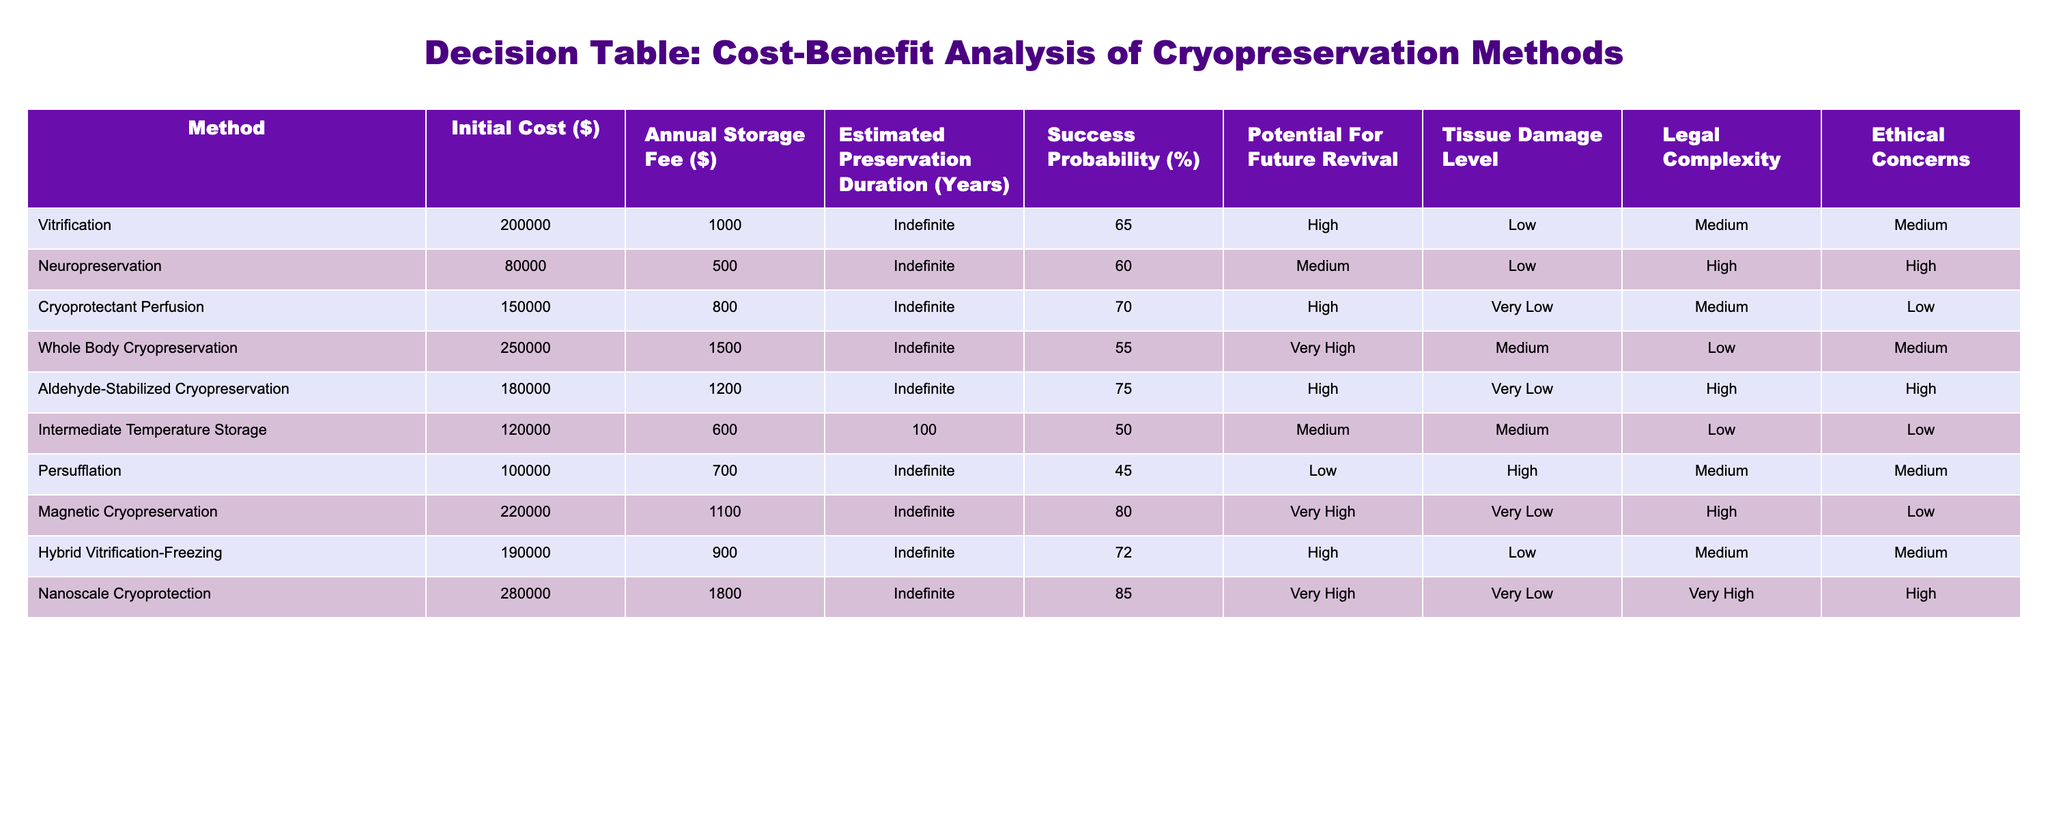What is the initial cost of Neuropreservation? The table lists the initial cost for Neuropreservation, which is $80,000.
Answer: 80,000 Which method has the highest success probability? In the table, Nanoscale Cryoprotection shows the highest success probability at 85%.
Answer: 85% What is the average annual storage fee for all methods? To find the average annual storage fee, we sum the storage fees: 1000 + 500 + 800 + 1500 + 1200 + 600 + 700 + 1100 + 1800 = 8200. Then, we divide by the number of methods (9): 8200/9 = approximately 911.11.
Answer: Approximately 911.11 Is the potential for future revival low for any methods? By reviewing the table, it can be observed that the potential for future revival is labeled as low for both Persufflation and some other methods. Therefore, it is true that at least two methods have low potential for future revival.
Answer: Yes Which method has the lowest tissue damage level and what is its success probability? The methods with the lowest tissue damage level are Cryoprotectant Perfusion and Aldehyde-Stabilized Cryopreservation, both displaying a tissue damage level of Very Low. Cryoprotectant Perfusion has a success probability of 70%, while Aldehyde-Stabilized Cryopreservation has 75%. Thus, Aldehyde-Stabilized Cryopreservation has the higher success probability at 75%.
Answer: Aldehyde-Stabilized Cryopreservation, 75% Which cryopreservation method is both high in success probability and very low in ethical concerns? The table reveals that Nanoscale Cryoprotection is the only method identified that has a success probability of 85% and is categorized as having very low ethical concerns.
Answer: Nanoscale Cryoprotection What is the cost difference between Whole Body Cryopreservation and Magnetic Cryopreservation? The initial cost of Whole Body Cryopreservation is $250,000 and that of Magnetic Cryopreservation is $220,000. Calculating the difference, we find $250,000 - $220,000 = $30,000.
Answer: 30,000 Are the legal complexities associated with Vitrification and Neuropreservation the same? By examining the table, Vitrification has a legal complexity rating of Medium, while Neuropreservation has a rating of High. Since these ratings are different, the answer to the question is no.
Answer: No Which method has the highest initial cost and what is its success probability? According to the table, Nanoscale Cryoprotection has the highest initial cost of $280,000 and a success probability of 85%.
Answer: Nanoscale Cryoprotection, 85% 